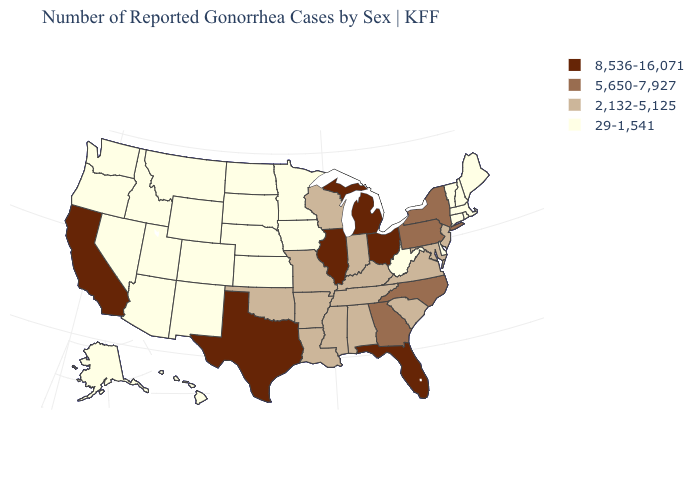Does South Carolina have a lower value than Illinois?
Be succinct. Yes. What is the highest value in states that border Connecticut?
Be succinct. 5,650-7,927. What is the highest value in the USA?
Answer briefly. 8,536-16,071. Is the legend a continuous bar?
Concise answer only. No. What is the value of Michigan?
Be succinct. 8,536-16,071. Does the map have missing data?
Give a very brief answer. No. What is the value of West Virginia?
Concise answer only. 29-1,541. Does Massachusetts have the lowest value in the Northeast?
Give a very brief answer. Yes. Which states hav the highest value in the South?
Write a very short answer. Florida, Texas. Which states have the lowest value in the MidWest?
Keep it brief. Iowa, Kansas, Minnesota, Nebraska, North Dakota, South Dakota. Among the states that border Rhode Island , which have the highest value?
Short answer required. Connecticut, Massachusetts. What is the lowest value in the MidWest?
Concise answer only. 29-1,541. Name the states that have a value in the range 2,132-5,125?
Quick response, please. Alabama, Arkansas, Indiana, Kentucky, Louisiana, Maryland, Mississippi, Missouri, New Jersey, Oklahoma, South Carolina, Tennessee, Virginia, Wisconsin. Which states have the lowest value in the West?
Answer briefly. Alaska, Arizona, Colorado, Hawaii, Idaho, Montana, Nevada, New Mexico, Oregon, Utah, Washington, Wyoming. Among the states that border New York , does Vermont have the lowest value?
Give a very brief answer. Yes. 